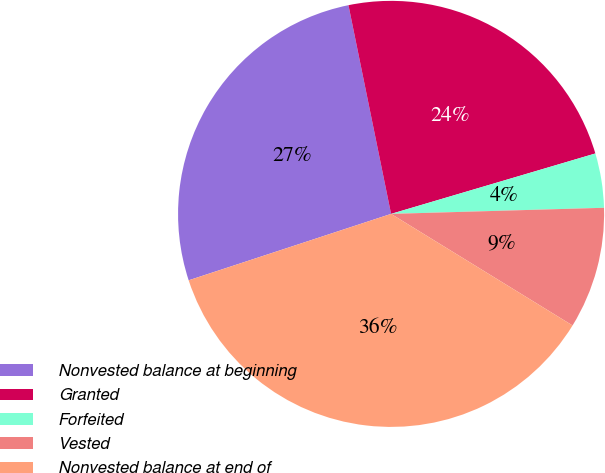Convert chart to OTSL. <chart><loc_0><loc_0><loc_500><loc_500><pie_chart><fcel>Nonvested balance at beginning<fcel>Granted<fcel>Forfeited<fcel>Vested<fcel>Nonvested balance at end of<nl><fcel>26.84%<fcel>23.63%<fcel>4.12%<fcel>9.23%<fcel>36.18%<nl></chart> 